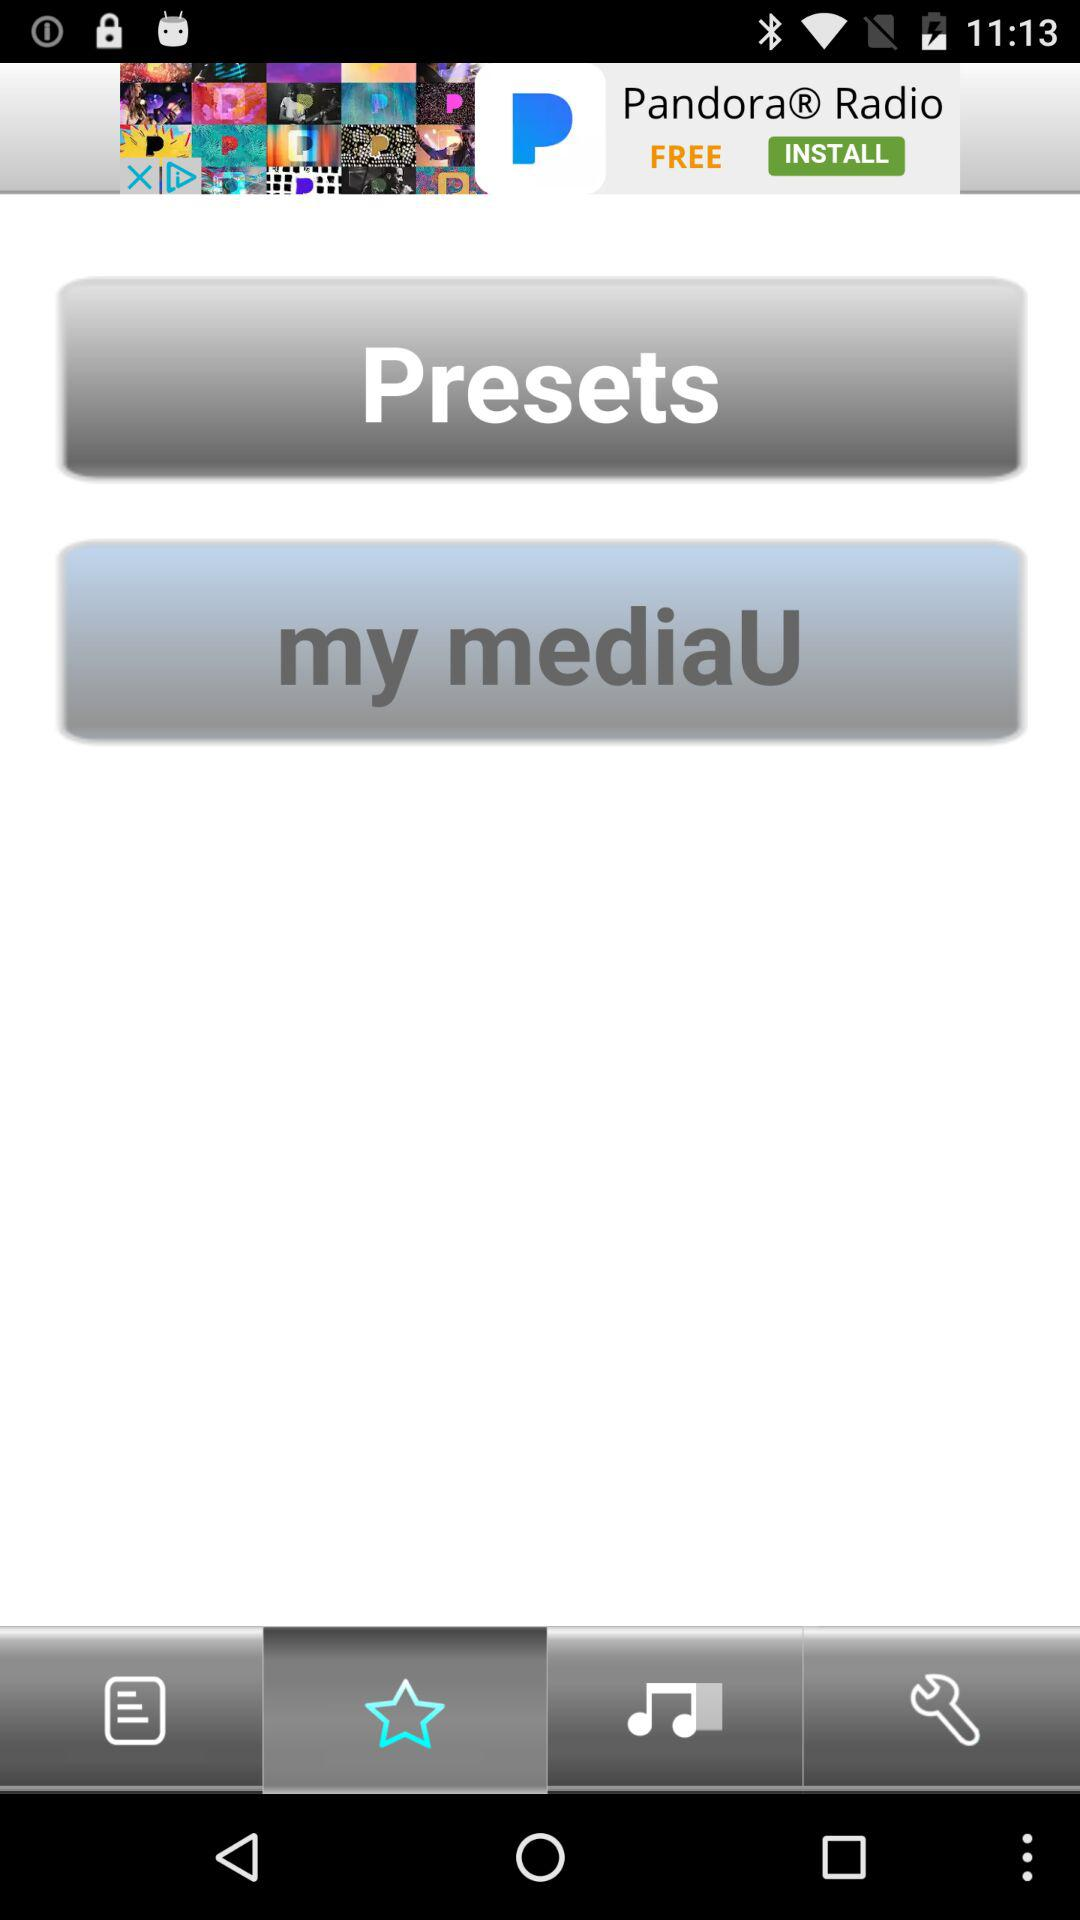Which tab has been selected? The selected tab is "Favorites". 